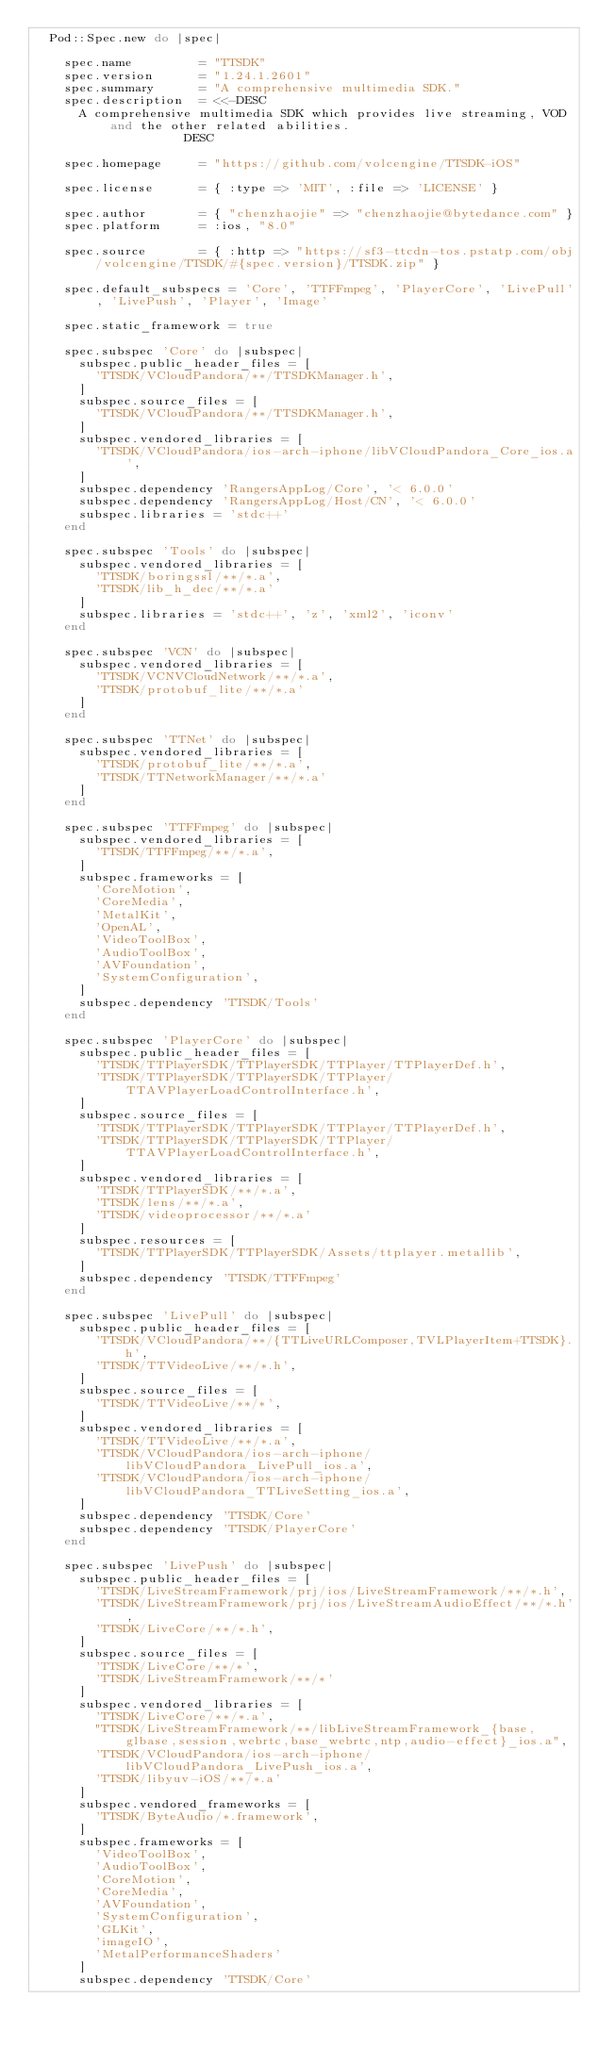<code> <loc_0><loc_0><loc_500><loc_500><_Ruby_>  Pod::Spec.new do |spec|

    spec.name         = "TTSDK"
    spec.version      = "1.24.1.2601"
    spec.summary      = "A comprehensive multimedia SDK."
    spec.description  = <<-DESC
      A comprehensive multimedia SDK which provides live streaming, VOD and the other related abilities.
                    DESC

    spec.homepage     = "https://github.com/volcengine/TTSDK-iOS"

    spec.license      = { :type => 'MIT', :file => 'LICENSE' }

    spec.author       = { "chenzhaojie" => "chenzhaojie@bytedance.com" }
    spec.platform     = :ios, "8.0"

    spec.source       = { :http => "https://sf3-ttcdn-tos.pstatp.com/obj/volcengine/TTSDK/#{spec.version}/TTSDK.zip" }
    
    spec.default_subspecs = 'Core', 'TTFFmpeg', 'PlayerCore', 'LivePull', 'LivePush', 'Player', 'Image'

    spec.static_framework = true
    
    spec.subspec 'Core' do |subspec|
      subspec.public_header_files = [
        'TTSDK/VCloudPandora/**/TTSDKManager.h',
      ]
      subspec.source_files = [
        'TTSDK/VCloudPandora/**/TTSDKManager.h',
      ]
      subspec.vendored_libraries = [
        'TTSDK/VCloudPandora/ios-arch-iphone/libVCloudPandora_Core_ios.a',
      ]
      subspec.dependency 'RangersAppLog/Core', '< 6.0.0'
      subspec.dependency 'RangersAppLog/Host/CN', '< 6.0.0'
      subspec.libraries = 'stdc++'
    end

    spec.subspec 'Tools' do |subspec| 
      subspec.vendored_libraries = [
        'TTSDK/boringssl/**/*.a',
        'TTSDK/lib_h_dec/**/*.a'
      ]
      subspec.libraries = 'stdc++', 'z', 'xml2', 'iconv'
    end

    spec.subspec 'VCN' do |subspec|
      subspec.vendored_libraries = [
        'TTSDK/VCNVCloudNetwork/**/*.a',
        'TTSDK/protobuf_lite/**/*.a'
      ]
    end

    spec.subspec 'TTNet' do |subspec| 
      subspec.vendored_libraries = [
        'TTSDK/protobuf_lite/**/*.a',
        'TTSDK/TTNetworkManager/**/*.a'
      ]
    end

    spec.subspec 'TTFFmpeg' do |subspec|
      subspec.vendored_libraries = [
        'TTSDK/TTFFmpeg/**/*.a',
      ]
      subspec.frameworks = [
        'CoreMotion',
        'CoreMedia',
        'MetalKit',
        'OpenAL',
        'VideoToolBox',
        'AudioToolBox',
        'AVFoundation',
        'SystemConfiguration',
      ]
      subspec.dependency 'TTSDK/Tools'
    end

    spec.subspec 'PlayerCore' do |subspec|
      subspec.public_header_files = [
        'TTSDK/TTPlayerSDK/TTPlayerSDK/TTPlayer/TTPlayerDef.h',
        'TTSDK/TTPlayerSDK/TTPlayerSDK/TTPlayer/TTAVPlayerLoadControlInterface.h',
      ]
      subspec.source_files = [
        'TTSDK/TTPlayerSDK/TTPlayerSDK/TTPlayer/TTPlayerDef.h',
        'TTSDK/TTPlayerSDK/TTPlayerSDK/TTPlayer/TTAVPlayerLoadControlInterface.h',
      ]
      subspec.vendored_libraries = [
        'TTSDK/TTPlayerSDK/**/*.a',
        'TTSDK/lens/**/*.a',
        'TTSDK/videoprocessor/**/*.a'
      ]
      subspec.resources = [
        'TTSDK/TTPlayerSDK/TTPlayerSDK/Assets/ttplayer.metallib',
      ]
      subspec.dependency 'TTSDK/TTFFmpeg'
    end

    spec.subspec 'LivePull' do |subspec|
      subspec.public_header_files = [
        'TTSDK/VCloudPandora/**/{TTLiveURLComposer,TVLPlayerItem+TTSDK}.h',
        'TTSDK/TTVideoLive/**/*.h',
      ]
      subspec.source_files = [
        'TTSDK/TTVideoLive/**/*',
      ]
      subspec.vendored_libraries = [
        'TTSDK/TTVideoLive/**/*.a',
        'TTSDK/VCloudPandora/ios-arch-iphone/libVCloudPandora_LivePull_ios.a',
        'TTSDK/VCloudPandora/ios-arch-iphone/libVCloudPandora_TTLiveSetting_ios.a',
      ]
      subspec.dependency 'TTSDK/Core'
      subspec.dependency 'TTSDK/PlayerCore'
    end

    spec.subspec 'LivePush' do |subspec|
      subspec.public_header_files = [
        'TTSDK/LiveStreamFramework/prj/ios/LiveStreamFramework/**/*.h',
        'TTSDK/LiveStreamFramework/prj/ios/LiveStreamAudioEffect/**/*.h',
        'TTSDK/LiveCore/**/*.h',
      ]
      subspec.source_files = [
        'TTSDK/LiveCore/**/*',
        'TTSDK/LiveStreamFramework/**/*'
      ]
      subspec.vendored_libraries = [
        'TTSDK/LiveCore/**/*.a',
        "TTSDK/LiveStreamFramework/**/libLiveStreamFramework_{base,glbase,session,webrtc,base_webrtc,ntp,audio-effect}_ios.a",
        'TTSDK/VCloudPandora/ios-arch-iphone/libVCloudPandora_LivePush_ios.a',
        'TTSDK/libyuv-iOS/**/*.a'
      ]
      subspec.vendored_frameworks = [
        'TTSDK/ByteAudio/*.framework',
      ]
      subspec.frameworks = [
        'VideoToolBox',
        'AudioToolBox',
        'CoreMotion',
        'CoreMedia',
        'AVFoundation',
        'SystemConfiguration',
        'GLKit',
        'imageIO',
        'MetalPerformanceShaders'
      ]
      subspec.dependency 'TTSDK/Core'</code> 